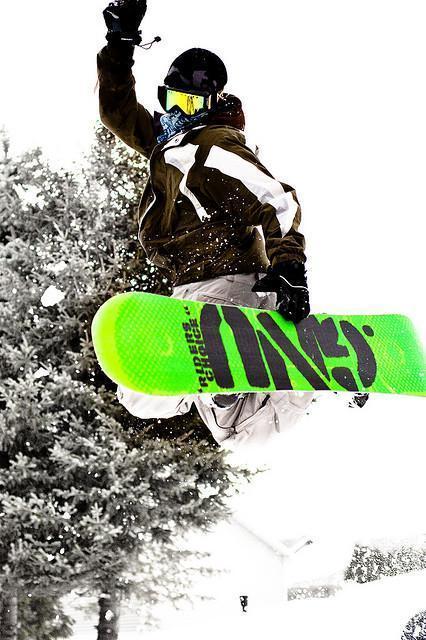How many stacks of bowls are there?
Give a very brief answer. 0. 